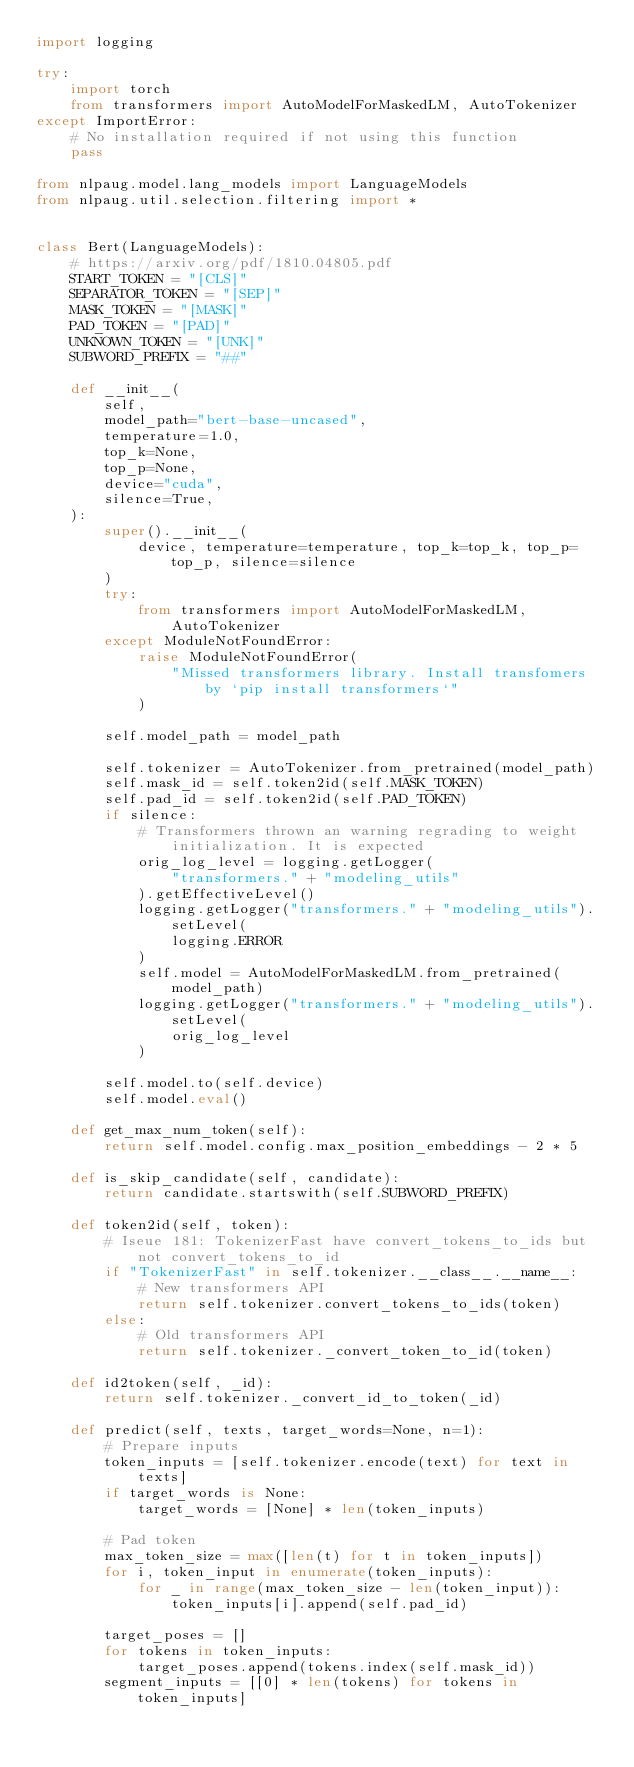Convert code to text. <code><loc_0><loc_0><loc_500><loc_500><_Python_>import logging

try:
    import torch
    from transformers import AutoModelForMaskedLM, AutoTokenizer
except ImportError:
    # No installation required if not using this function
    pass

from nlpaug.model.lang_models import LanguageModels
from nlpaug.util.selection.filtering import *


class Bert(LanguageModels):
    # https://arxiv.org/pdf/1810.04805.pdf
    START_TOKEN = "[CLS]"
    SEPARATOR_TOKEN = "[SEP]"
    MASK_TOKEN = "[MASK]"
    PAD_TOKEN = "[PAD]"
    UNKNOWN_TOKEN = "[UNK]"
    SUBWORD_PREFIX = "##"

    def __init__(
        self,
        model_path="bert-base-uncased",
        temperature=1.0,
        top_k=None,
        top_p=None,
        device="cuda",
        silence=True,
    ):
        super().__init__(
            device, temperature=temperature, top_k=top_k, top_p=top_p, silence=silence
        )
        try:
            from transformers import AutoModelForMaskedLM, AutoTokenizer
        except ModuleNotFoundError:
            raise ModuleNotFoundError(
                "Missed transformers library. Install transfomers by `pip install transformers`"
            )

        self.model_path = model_path

        self.tokenizer = AutoTokenizer.from_pretrained(model_path)
        self.mask_id = self.token2id(self.MASK_TOKEN)
        self.pad_id = self.token2id(self.PAD_TOKEN)
        if silence:
            # Transformers thrown an warning regrading to weight initialization. It is expected
            orig_log_level = logging.getLogger(
                "transformers." + "modeling_utils"
            ).getEffectiveLevel()
            logging.getLogger("transformers." + "modeling_utils").setLevel(
                logging.ERROR
            )
            self.model = AutoModelForMaskedLM.from_pretrained(model_path)
            logging.getLogger("transformers." + "modeling_utils").setLevel(
                orig_log_level
            )

        self.model.to(self.device)
        self.model.eval()

    def get_max_num_token(self):
        return self.model.config.max_position_embeddings - 2 * 5

    def is_skip_candidate(self, candidate):
        return candidate.startswith(self.SUBWORD_PREFIX)

    def token2id(self, token):
        # Iseue 181: TokenizerFast have convert_tokens_to_ids but not convert_tokens_to_id
        if "TokenizerFast" in self.tokenizer.__class__.__name__:
            # New transformers API
            return self.tokenizer.convert_tokens_to_ids(token)
        else:
            # Old transformers API
            return self.tokenizer._convert_token_to_id(token)

    def id2token(self, _id):
        return self.tokenizer._convert_id_to_token(_id)

    def predict(self, texts, target_words=None, n=1):
        # Prepare inputs
        token_inputs = [self.tokenizer.encode(text) for text in texts]
        if target_words is None:
            target_words = [None] * len(token_inputs)

        # Pad token
        max_token_size = max([len(t) for t in token_inputs])
        for i, token_input in enumerate(token_inputs):
            for _ in range(max_token_size - len(token_input)):
                token_inputs[i].append(self.pad_id)

        target_poses = []
        for tokens in token_inputs:
            target_poses.append(tokens.index(self.mask_id))
        segment_inputs = [[0] * len(tokens) for tokens in token_inputs]</code> 